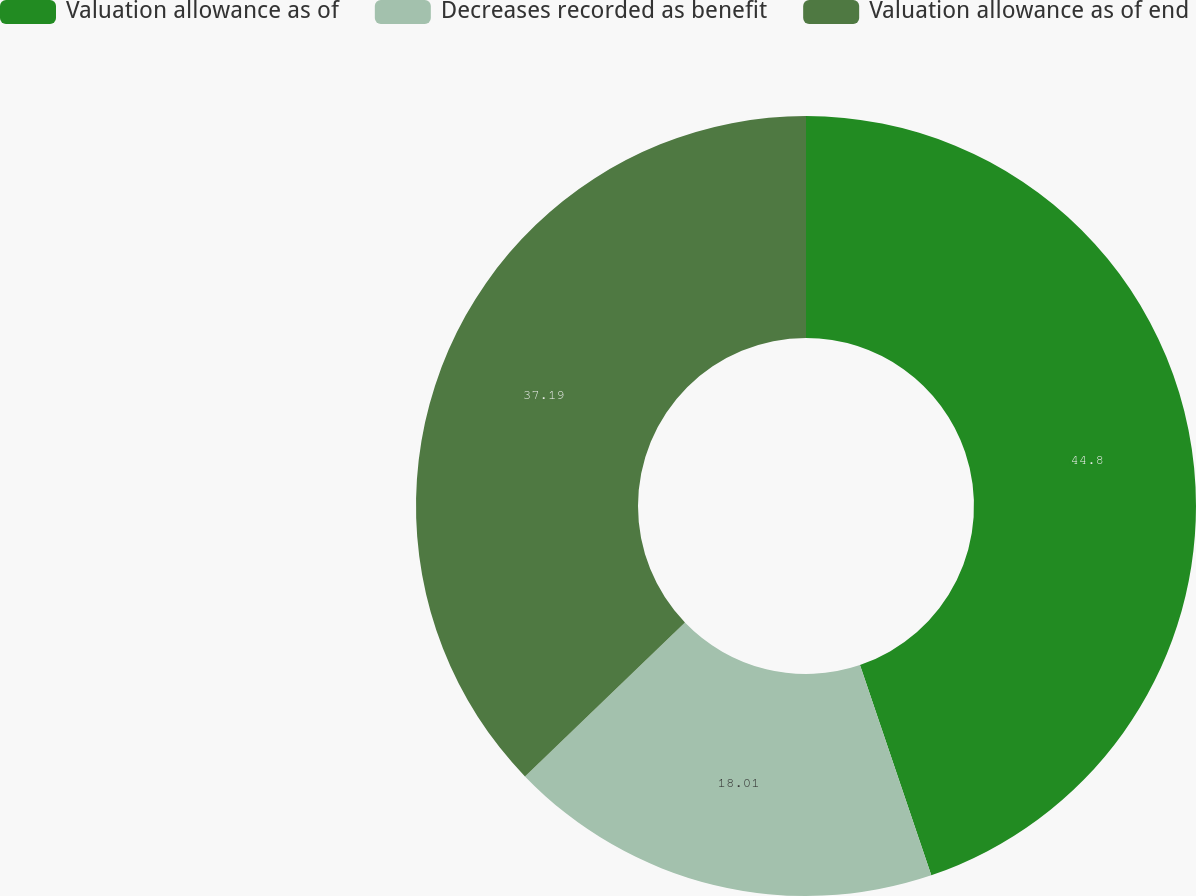Convert chart to OTSL. <chart><loc_0><loc_0><loc_500><loc_500><pie_chart><fcel>Valuation allowance as of<fcel>Decreases recorded as benefit<fcel>Valuation allowance as of end<nl><fcel>44.79%<fcel>18.01%<fcel>37.19%<nl></chart> 